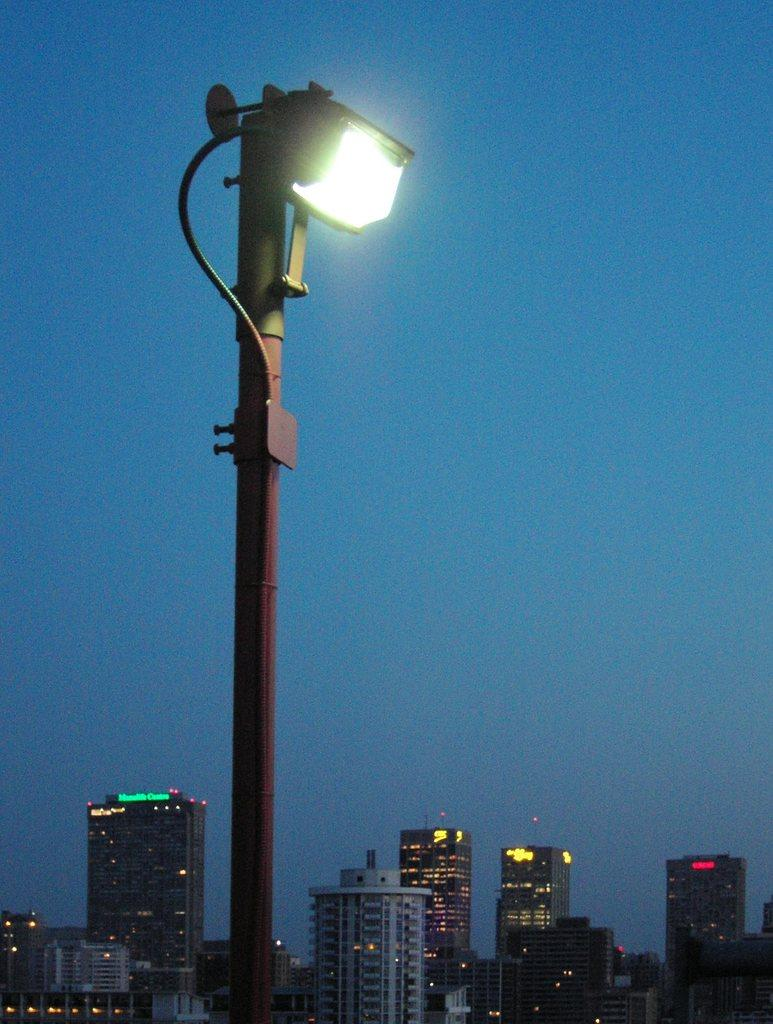What is the main object in the foreground of the image? There is a street light in the image. What can be seen in the distance behind the street light? There are buildings in the background of the image. What part of the natural environment is visible in the image? The sky is visible in the background of the image. What type of fuel is being used by the beetle in the image? There is no beetle present in the image, so it is not possible to determine what type of fuel it might be using. 